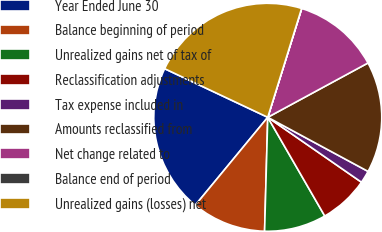Convert chart. <chart><loc_0><loc_0><loc_500><loc_500><pie_chart><fcel>Year Ended June 30<fcel>Balance beginning of period<fcel>Unrealized gains net of tax of<fcel>Reclassification adjustments<fcel>Tax expense included in<fcel>Amounts reclassified from<fcel>Net change related to<fcel>Balance end of period<fcel>Unrealized gains (losses) net<nl><fcel>21.04%<fcel>10.53%<fcel>8.78%<fcel>7.02%<fcel>1.77%<fcel>15.78%<fcel>12.28%<fcel>0.02%<fcel>22.79%<nl></chart> 